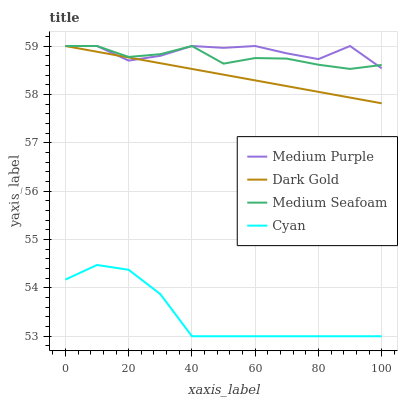Does Cyan have the minimum area under the curve?
Answer yes or no. Yes. Does Medium Purple have the maximum area under the curve?
Answer yes or no. Yes. Does Medium Seafoam have the minimum area under the curve?
Answer yes or no. No. Does Medium Seafoam have the maximum area under the curve?
Answer yes or no. No. Is Dark Gold the smoothest?
Answer yes or no. Yes. Is Medium Purple the roughest?
Answer yes or no. Yes. Is Cyan the smoothest?
Answer yes or no. No. Is Cyan the roughest?
Answer yes or no. No. Does Cyan have the lowest value?
Answer yes or no. Yes. Does Medium Seafoam have the lowest value?
Answer yes or no. No. Does Dark Gold have the highest value?
Answer yes or no. Yes. Does Cyan have the highest value?
Answer yes or no. No. Is Cyan less than Medium Seafoam?
Answer yes or no. Yes. Is Medium Purple greater than Cyan?
Answer yes or no. Yes. Does Medium Seafoam intersect Medium Purple?
Answer yes or no. Yes. Is Medium Seafoam less than Medium Purple?
Answer yes or no. No. Is Medium Seafoam greater than Medium Purple?
Answer yes or no. No. Does Cyan intersect Medium Seafoam?
Answer yes or no. No. 